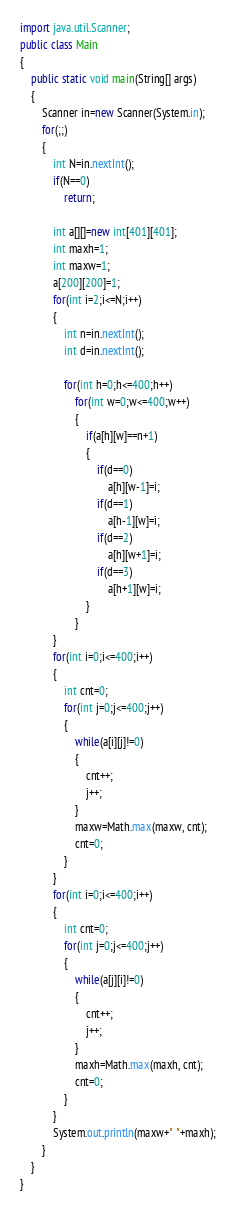Convert code to text. <code><loc_0><loc_0><loc_500><loc_500><_Java_>import java.util.Scanner;
public class Main
{
	public static void main(String[] args) 
	{
		Scanner in=new Scanner(System.in);
		for(;;)
		{
			int N=in.nextInt();
			if(N==0)
				return;
			
			int a[][]=new int[401][401];
			int maxh=1;
			int maxw=1;
			a[200][200]=1;
			for(int i=2;i<=N;i++)
			{
				int n=in.nextInt();
				int d=in.nextInt();
				
				for(int h=0;h<=400;h++)
					for(int w=0;w<=400;w++)
					{
						if(a[h][w]==n+1)
						{
							if(d==0)
								a[h][w-1]=i;
							if(d==1)
								a[h-1][w]=i;
							if(d==2)
								a[h][w+1]=i;
							if(d==3)
								a[h+1][w]=i;
						}
					}
			}
			for(int i=0;i<=400;i++)
			{
				int cnt=0;
				for(int j=0;j<=400;j++)
				{
					while(a[i][j]!=0)
					{
						cnt++;
						j++;
					}
					maxw=Math.max(maxw, cnt);
					cnt=0;
				}
			}
			for(int i=0;i<=400;i++)
			{
				int cnt=0;
				for(int j=0;j<=400;j++)
				{
					while(a[j][i]!=0)
					{
						cnt++;
						j++;
					}
					maxh=Math.max(maxh, cnt);
					cnt=0;
				}
			}
			System.out.println(maxw+" "+maxh);
		}
	}
}</code> 